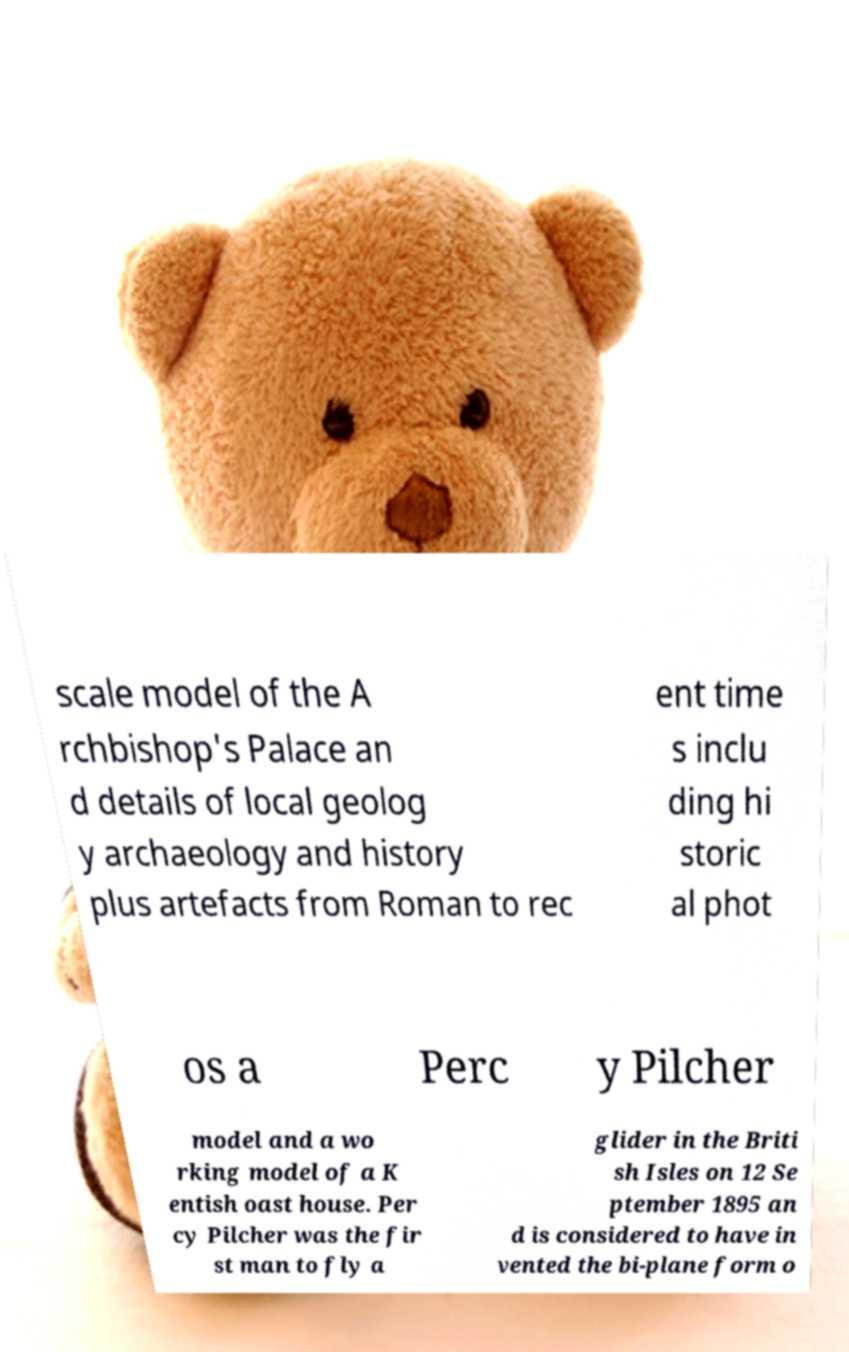For documentation purposes, I need the text within this image transcribed. Could you provide that? scale model of the A rchbishop's Palace an d details of local geolog y archaeology and history plus artefacts from Roman to rec ent time s inclu ding hi storic al phot os a Perc y Pilcher model and a wo rking model of a K entish oast house. Per cy Pilcher was the fir st man to fly a glider in the Briti sh Isles on 12 Se ptember 1895 an d is considered to have in vented the bi-plane form o 